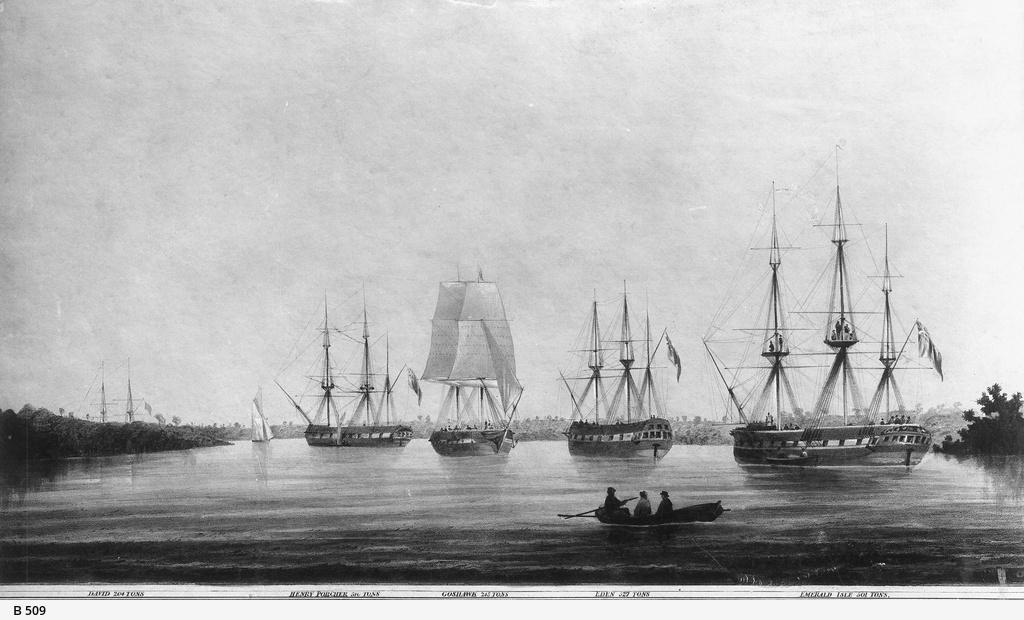What type of artwork is depicted in the image? The image is a sketch. What can be seen on the water in the image? There are ships on the water in the image. What type of vegetation is on the right side of the image? There are trees on the right side of the image. What is the condition of the sky in the image? The sky is clear in the image. What type of flowers are blooming on the left side of the image? There are no flowers present in the image; it features a sketch of ships on the water with trees on the right side and a clear sky. 